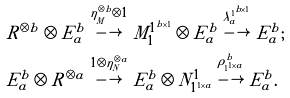<formula> <loc_0><loc_0><loc_500><loc_500>& R ^ { \otimes b } \otimes E _ { a } ^ { b } \overset { \eta _ { _ { M } } ^ { \otimes b } \otimes { 1 } } { \longrightarrow } M _ { 1 } ^ { 1 ^ { b \times 1 } } \otimes E _ { a } ^ { b } \overset { \lambda _ { a } ^ { 1 ^ { b \times 1 } } } { \longrightarrow } E _ { a } ^ { b } ; \\ & E _ { a } ^ { b } \otimes R ^ { \otimes a } \overset { { 1 } \otimes \eta _ { N } ^ { \otimes a } } { \longrightarrow } E _ { a } ^ { b } \otimes N _ { 1 ^ { 1 \times a } } ^ { 1 } \overset { \rho _ { 1 ^ { 1 \times a } } ^ { b } } { \longrightarrow } E _ { a } ^ { b } .</formula> 